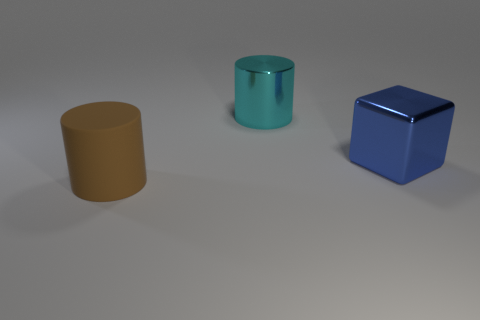Add 2 large brown cylinders. How many objects exist? 5 Subtract all cubes. How many objects are left? 2 Add 3 cyan metal things. How many cyan metal things exist? 4 Subtract 1 brown cylinders. How many objects are left? 2 Subtract all rubber blocks. Subtract all cyan things. How many objects are left? 2 Add 2 brown matte cylinders. How many brown matte cylinders are left? 3 